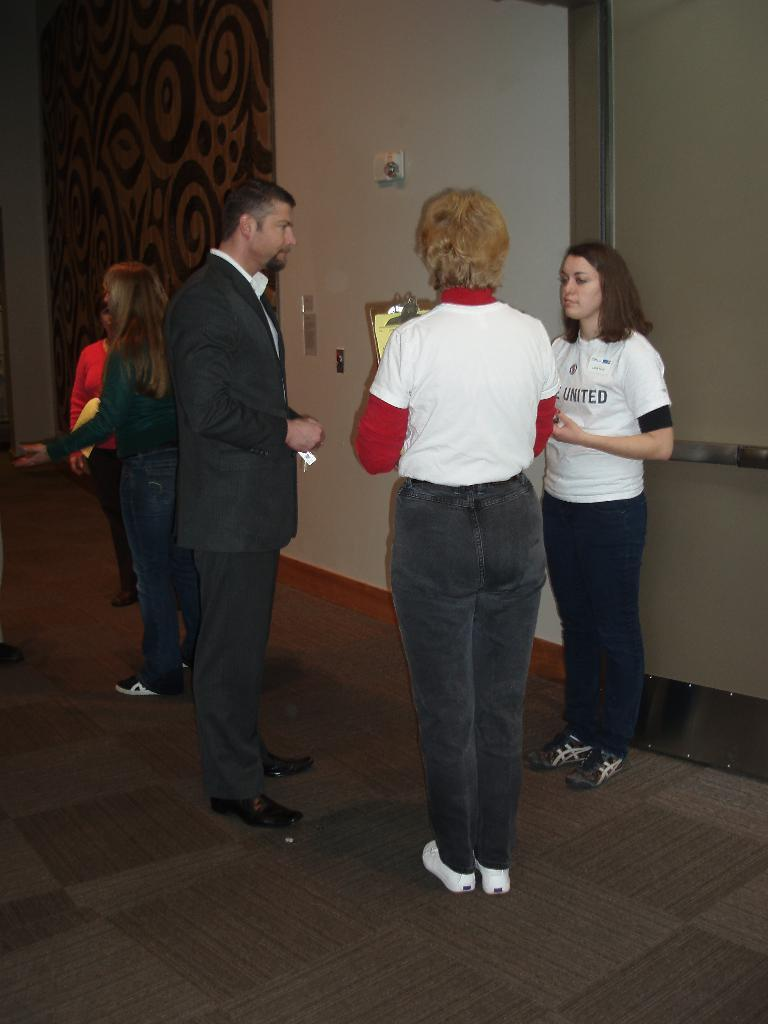What can be seen in the image? There are people standing in the image. Where are the people standing? The people are standing on a floor. What is visible in the background of the image? There is a wall in the background of the image. What features can be seen on the wall? There is a door in the wall and a curtain associated with the wall and door. What type of berry can be seen on the curtain in the image? There are no berries present on the curtain in the image. What design is featured on the ladybug in the image? There are no ladybugs present in the image. 